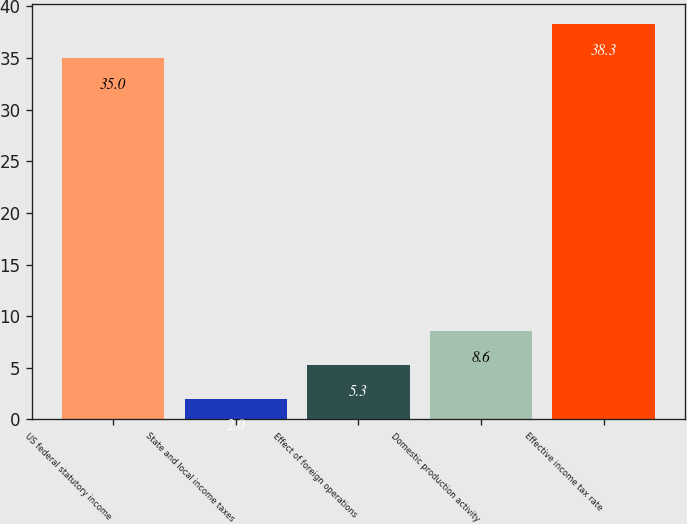Convert chart to OTSL. <chart><loc_0><loc_0><loc_500><loc_500><bar_chart><fcel>US federal statutory income<fcel>State and local income taxes<fcel>Effect of foreign operations<fcel>Domestic production activity<fcel>Effective income tax rate<nl><fcel>35<fcel>2<fcel>5.3<fcel>8.6<fcel>38.3<nl></chart> 